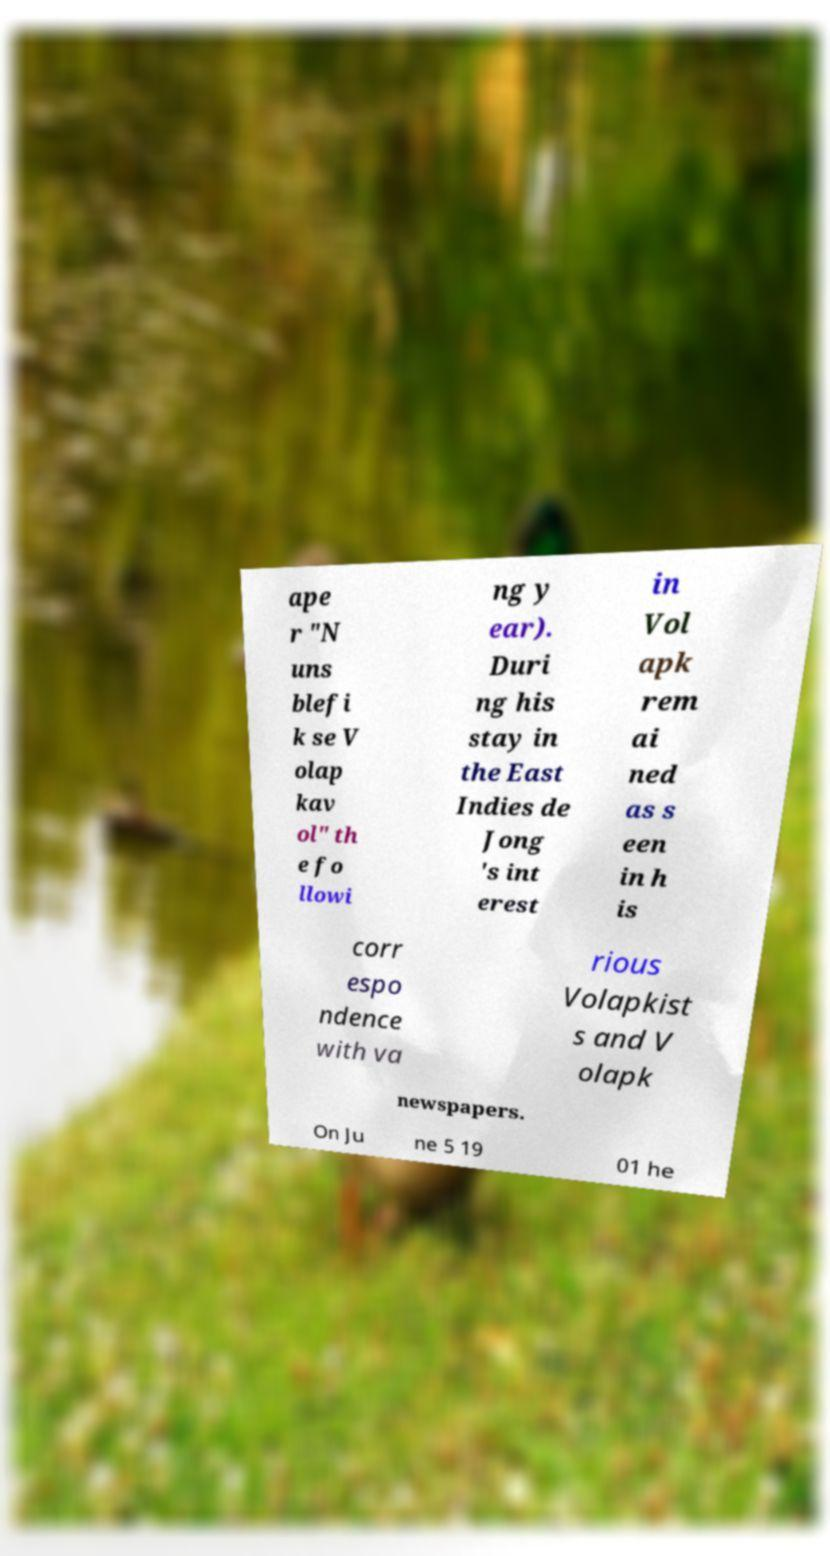There's text embedded in this image that I need extracted. Can you transcribe it verbatim? ape r "N uns blefi k se V olap kav ol" th e fo llowi ng y ear). Duri ng his stay in the East Indies de Jong 's int erest in Vol apk rem ai ned as s een in h is corr espo ndence with va rious Volapkist s and V olapk newspapers. On Ju ne 5 19 01 he 